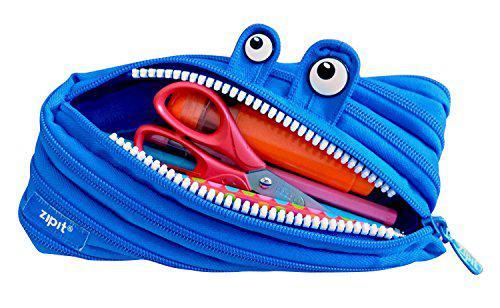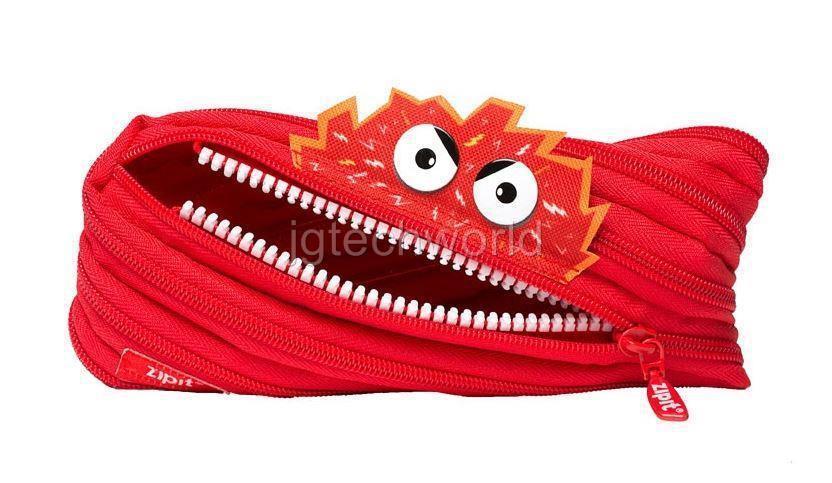The first image is the image on the left, the second image is the image on the right. Analyze the images presented: Is the assertion "There is a single pink bag in the image on the left." valid? Answer yes or no. No. 